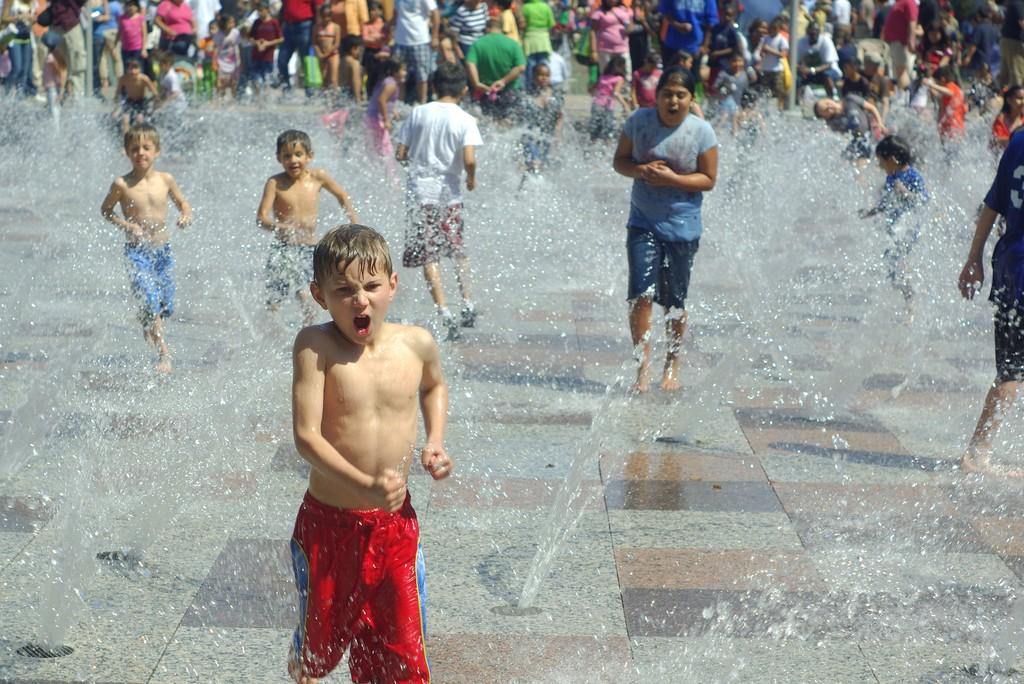What can be seen in the image that represents a source of water? There are fountains in the image. What else is present in the image besides the fountains? There is a group of people in the image. How can you describe the appearance of the people in the image? The people are wearing different color dresses. What channel are the people watching on their arm in the image? There is no mention of a channel or people watching anything on their arm in the image. 